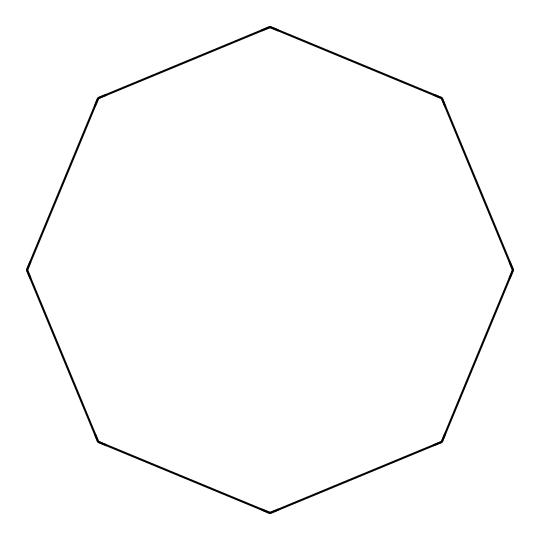What is the molecular formula for cyclooctane? The molecular formula can be determined by counting the carbon and hydrogen atoms in the structure. The cyclooctane structure shows 8 carbon atoms and 16 hydrogen atoms. Therefore, the molecular formula is C8H16.
Answer: C8H16 How many carbon atoms are in cyclooctane? By analyzing the SMILES representation, we can count the number of carbon atoms denoted by "C". In this case, there are 8 "C" symbols in total.
Answer: 8 What type of hybridization do the carbon atoms in cyclooctane exhibit? In cyclooctane, the carbon atoms are bonded in a cyclic manner, and each carbon is connected to two other carbons and two hydrogens. This arrangement features sp3 hybridization due to the tetravalent nature of carbon and the single bonds present.
Answer: sp3 What is the bond angle around the carbon atoms in cyclooctane? Cyclooctane has a non-planar structure due to its ring formation and generally exhibits bond angles close to 109.5 degrees, characteristic of tetrahedral geometry associated with sp3 hybridized carbon atoms.
Answer: 109.5 degrees What structural property makes cyclooctane less stable than other cycloalkanes? Cyclooctane experiences torsional strain and angle strain because of its larger ring size, causing greater repulsion between bonds in the structure compared to smaller cycloalkanes like cyclopropane or cyclobutane, thus leading to its lower stability.
Answer: strain How many hydrogen atoms are associated with each carbon atom in cyclooctane? Each carbon atom in cyclooctane is bonded to two hydrogen atoms because of its tetravalent nature and the way it connects with adjacent carbon atoms, leading to a total of 16 hydrogen atoms for 8 carbons.
Answer: 2 